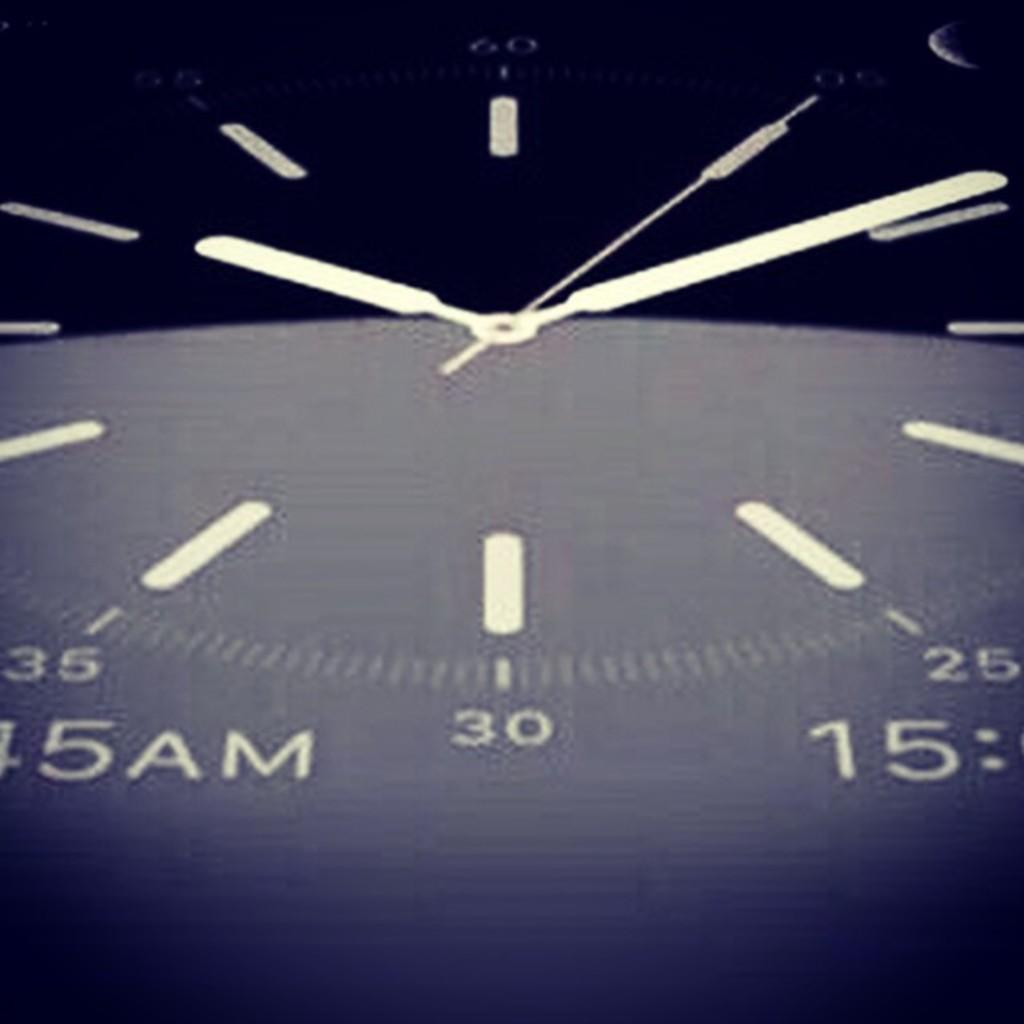<image>
Present a compact description of the photo's key features. A zoomed in look at a watch that shows 30. 